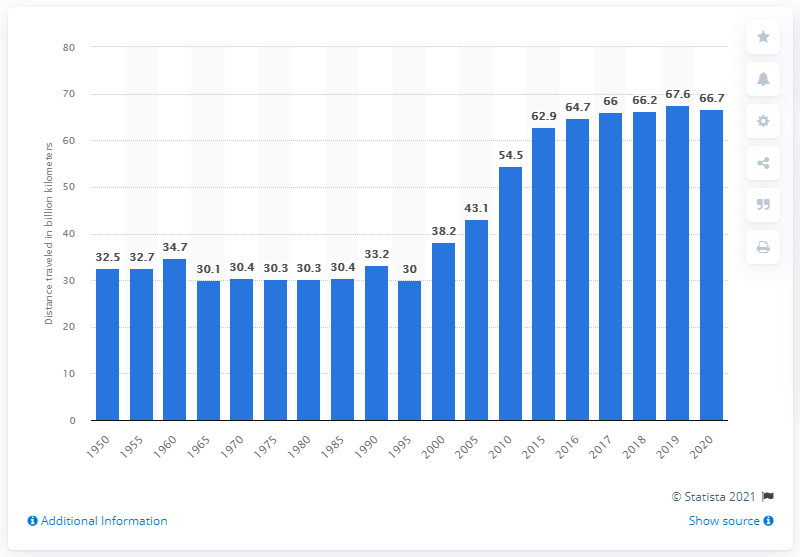List a handful of essential elements in this visual. The passengers traveled a total of 66.7 kilometers on national rail services between 1950 and 2020. 